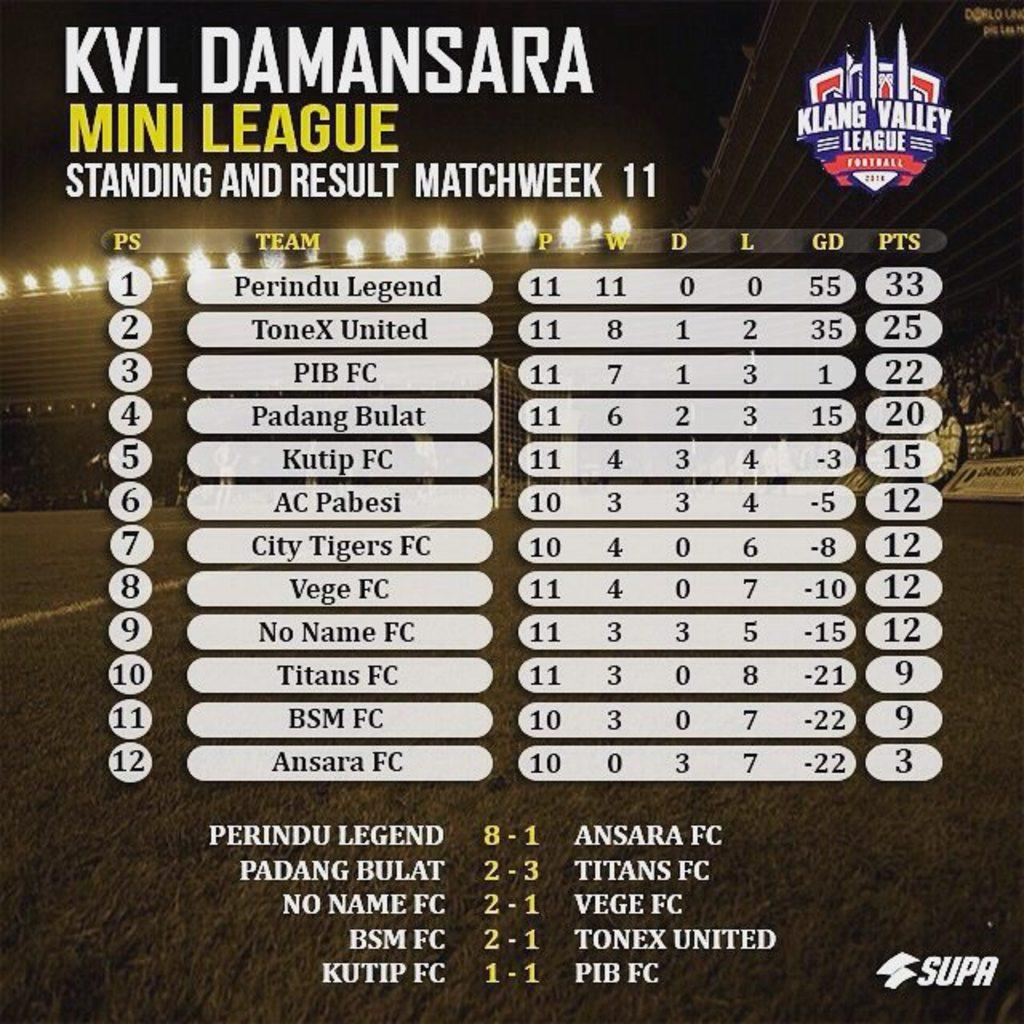<image>
Create a compact narrative representing the image presented. Some scores from sports games which have Mini League written above them. 